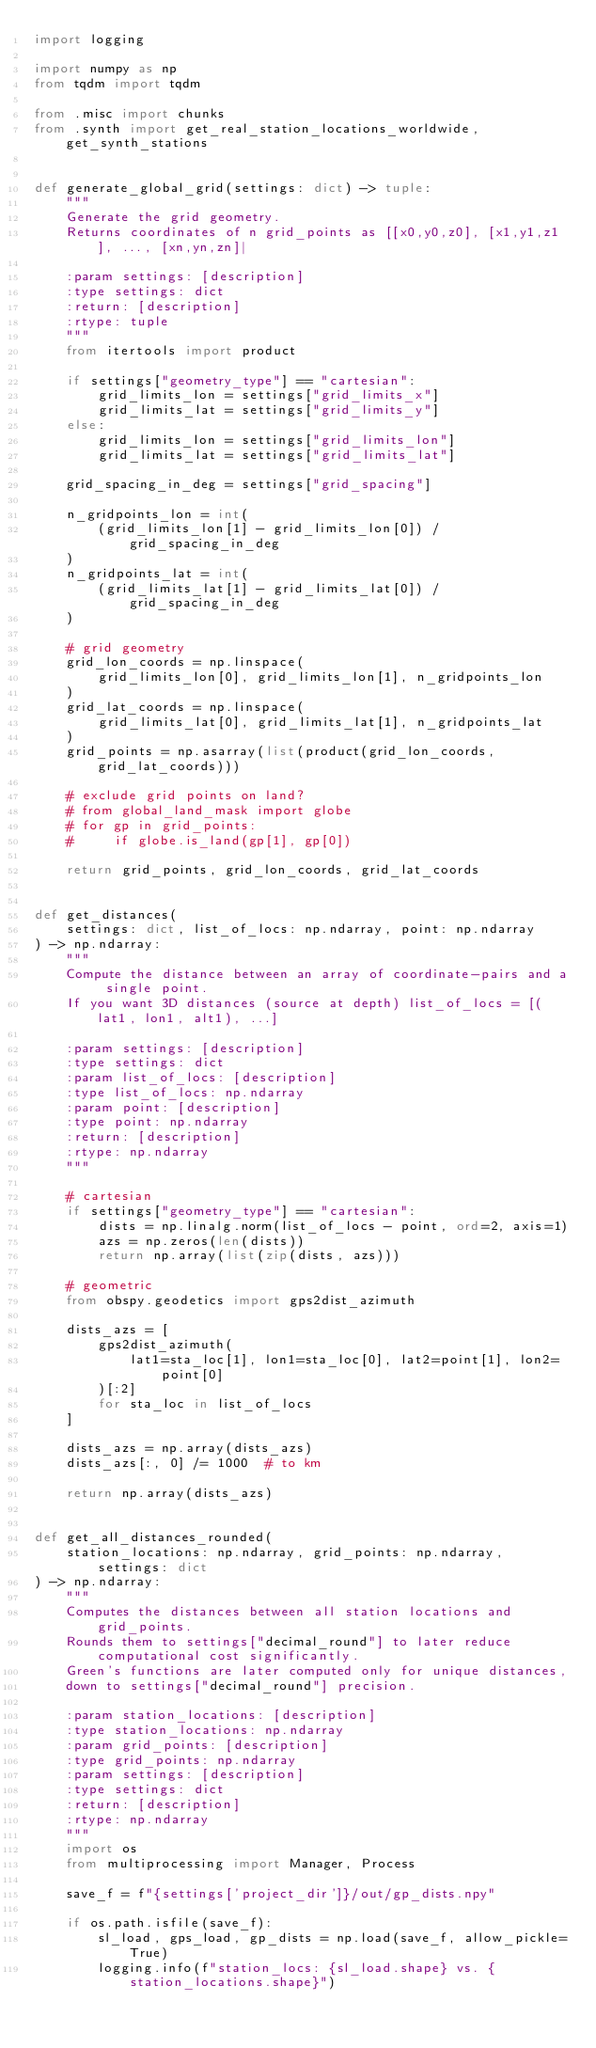Convert code to text. <code><loc_0><loc_0><loc_500><loc_500><_Python_>import logging

import numpy as np
from tqdm import tqdm

from .misc import chunks
from .synth import get_real_station_locations_worldwide, get_synth_stations


def generate_global_grid(settings: dict) -> tuple:
    """
    Generate the grid geometry.
    Returns coordinates of n grid_points as [[x0,y0,z0], [x1,y1,z1], ..., [xn,yn,zn]|

    :param settings: [description]
    :type settings: dict
    :return: [description]
    :rtype: tuple
    """
    from itertools import product

    if settings["geometry_type"] == "cartesian":
        grid_limits_lon = settings["grid_limits_x"]
        grid_limits_lat = settings["grid_limits_y"]
    else:
        grid_limits_lon = settings["grid_limits_lon"]
        grid_limits_lat = settings["grid_limits_lat"]

    grid_spacing_in_deg = settings["grid_spacing"]

    n_gridpoints_lon = int(
        (grid_limits_lon[1] - grid_limits_lon[0]) / grid_spacing_in_deg
    )
    n_gridpoints_lat = int(
        (grid_limits_lat[1] - grid_limits_lat[0]) / grid_spacing_in_deg
    )

    # grid geometry
    grid_lon_coords = np.linspace(
        grid_limits_lon[0], grid_limits_lon[1], n_gridpoints_lon
    )
    grid_lat_coords = np.linspace(
        grid_limits_lat[0], grid_limits_lat[1], n_gridpoints_lat
    )
    grid_points = np.asarray(list(product(grid_lon_coords, grid_lat_coords)))

    # exclude grid points on land?
    # from global_land_mask import globe
    # for gp in grid_points:
    #     if globe.is_land(gp[1], gp[0])

    return grid_points, grid_lon_coords, grid_lat_coords


def get_distances(
    settings: dict, list_of_locs: np.ndarray, point: np.ndarray
) -> np.ndarray:
    """
    Compute the distance between an array of coordinate-pairs and a single point.
    If you want 3D distances (source at depth) list_of_locs = [(lat1, lon1, alt1), ...]

    :param settings: [description]
    :type settings: dict
    :param list_of_locs: [description]
    :type list_of_locs: np.ndarray
    :param point: [description]
    :type point: np.ndarray
    :return: [description]
    :rtype: np.ndarray
    """

    # cartesian
    if settings["geometry_type"] == "cartesian":
        dists = np.linalg.norm(list_of_locs - point, ord=2, axis=1)
        azs = np.zeros(len(dists))
        return np.array(list(zip(dists, azs)))

    # geometric
    from obspy.geodetics import gps2dist_azimuth

    dists_azs = [
        gps2dist_azimuth(
            lat1=sta_loc[1], lon1=sta_loc[0], lat2=point[1], lon2=point[0]
        )[:2]
        for sta_loc in list_of_locs
    ]

    dists_azs = np.array(dists_azs)
    dists_azs[:, 0] /= 1000  # to km

    return np.array(dists_azs)


def get_all_distances_rounded(
    station_locations: np.ndarray, grid_points: np.ndarray, settings: dict
) -> np.ndarray:
    """
    Computes the distances between all station locations and grid_points.
    Rounds them to settings["decimal_round"] to later reduce computational cost significantly.
    Green's functions are later computed only for unique distances,
    down to settings["decimal_round"] precision.

    :param station_locations: [description]
    :type station_locations: np.ndarray
    :param grid_points: [description]
    :type grid_points: np.ndarray
    :param settings: [description]
    :type settings: dict
    :return: [description]
    :rtype: np.ndarray
    """
    import os
    from multiprocessing import Manager, Process

    save_f = f"{settings['project_dir']}/out/gp_dists.npy"

    if os.path.isfile(save_f):
        sl_load, gps_load, gp_dists = np.load(save_f, allow_pickle=True)
        logging.info(f"station_locs: {sl_load.shape} vs. {station_locations.shape}")</code> 